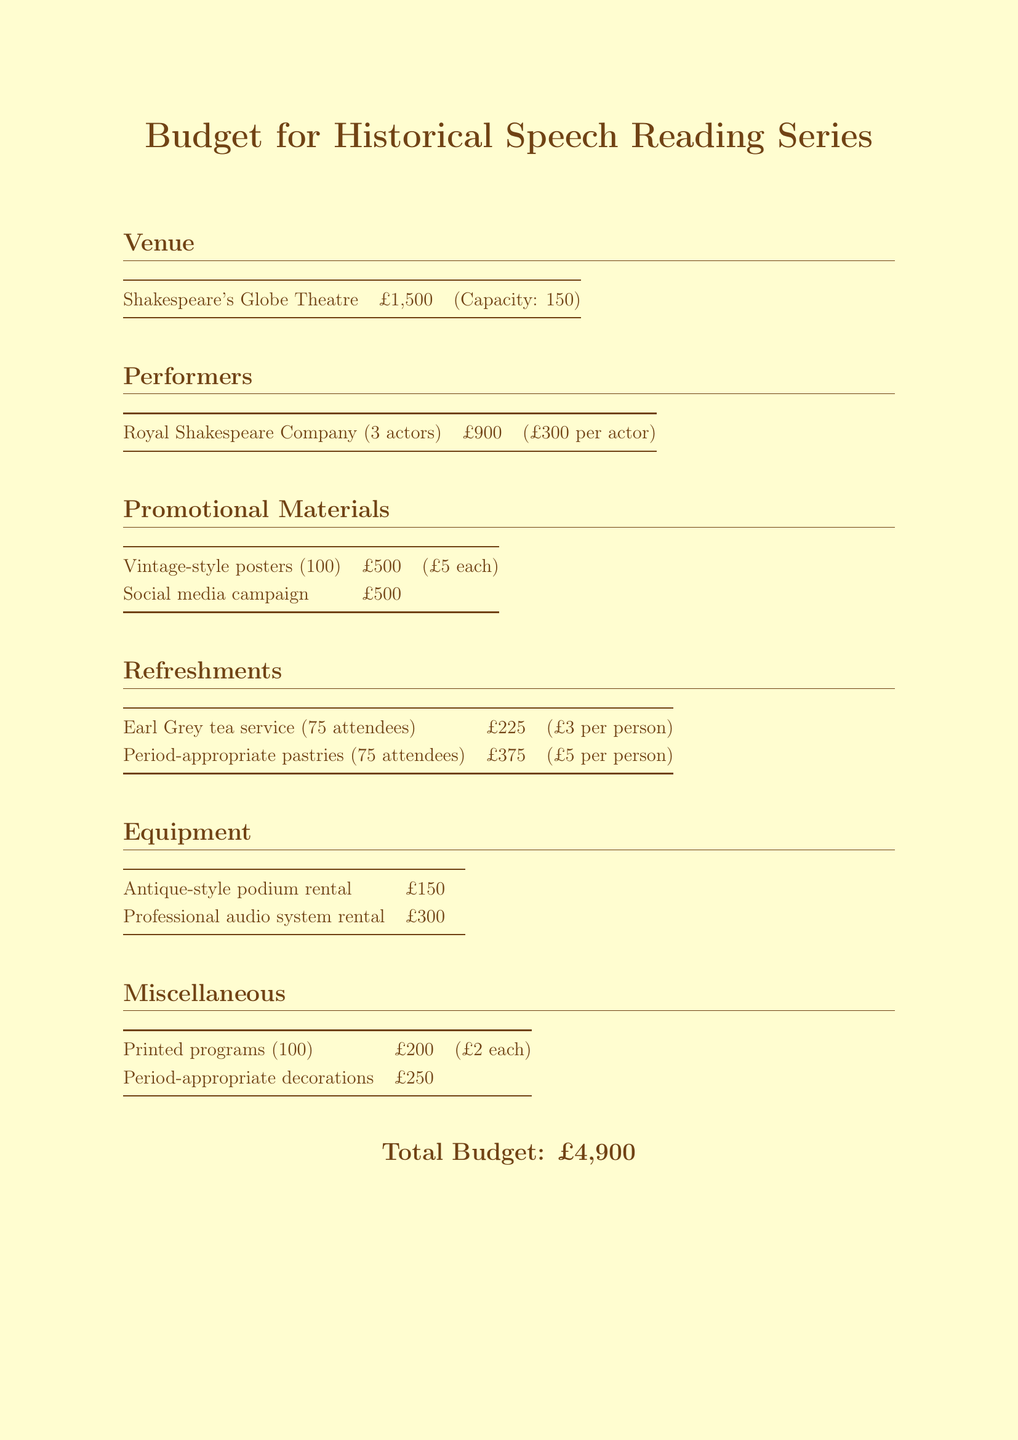What is the venue for the reading series? The venue is identified in the document and is vital for logistics and audience capacity.
Answer: Shakespeare's Globe Theatre How much does it cost to rent the antique-style podium? The rental cost for the podium is included in the equipment section, which outlines necessary expenses.
Answer: 150 What is the total cost for hiring the Royal Shakespeare Company? The total cost for the performers is presented, with specific details about their fees.
Answer: 900 How many attendees can the venue accommodate? The capacity of the venue is mentioned alongside its rental cost and is crucial for planning attendance.
Answer: 150 What is the budget for promotional materials? The promotional materials budget covers specific items that are essential for attracting an audience.
Answer: 1000 What type of tea service is included in the refreshments? The tea service is detailed in the refreshments section, as it contributes to the event's historical ambiance.
Answer: Earl Grey tea service How many printed programs are planned for the event? The number of printed programs is indicated, reflecting the distribution strategy for the audience.
Answer: 100 What is the total budget for the reading series? The total budget represents the overall financial planning for the event and reflects all expenditures listed.
Answer: 4900 